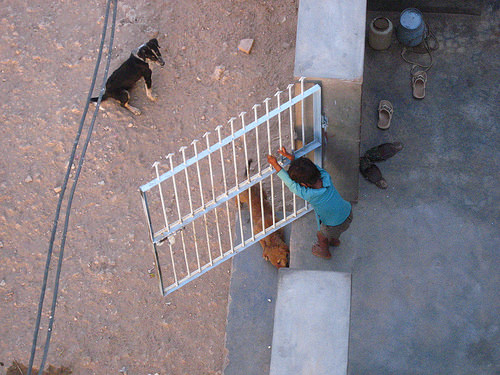<image>
Is the boy on the gate? Yes. Looking at the image, I can see the boy is positioned on top of the gate, with the gate providing support. Is there a kid in front of the dog? Yes. The kid is positioned in front of the dog, appearing closer to the camera viewpoint. 